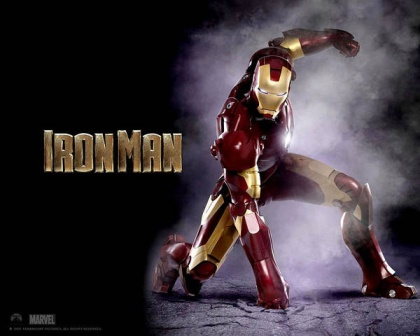Imagine Iron Man's suit has a hidden feature. What could it be, and how might it be used in a critical moment? A hidden feature in Iron Man's suit could be a 'Dimension Shift Mode,' allowing Tony Stark to phase into a parallel dimension or generate a temporary alternate reality field around him. In a critical moment where he is surrounded by enemies and escape seems impossible, he could activate this mode to vanish from the attackers' perception, reposition outside of danger, and surprise them from behind or even pass through solid obstacles unharmed. 